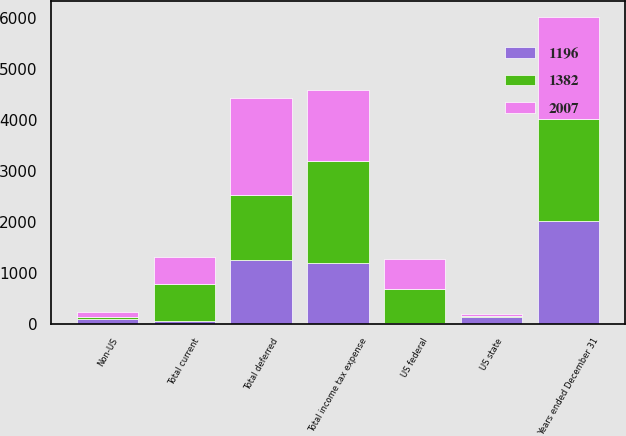Convert chart to OTSL. <chart><loc_0><loc_0><loc_500><loc_500><stacked_bar_chart><ecel><fcel>Years ended December 31<fcel>US federal<fcel>Non-US<fcel>US state<fcel>Total current<fcel>Total deferred<fcel>Total income tax expense<nl><fcel>1382<fcel>2012<fcel>657<fcel>52<fcel>19<fcel>728<fcel>1279<fcel>2007<nl><fcel>2007<fcel>2011<fcel>605<fcel>93<fcel>22<fcel>534<fcel>1916<fcel>1382<nl><fcel>1196<fcel>2010<fcel>13<fcel>80<fcel>137<fcel>44<fcel>1240<fcel>1196<nl></chart> 